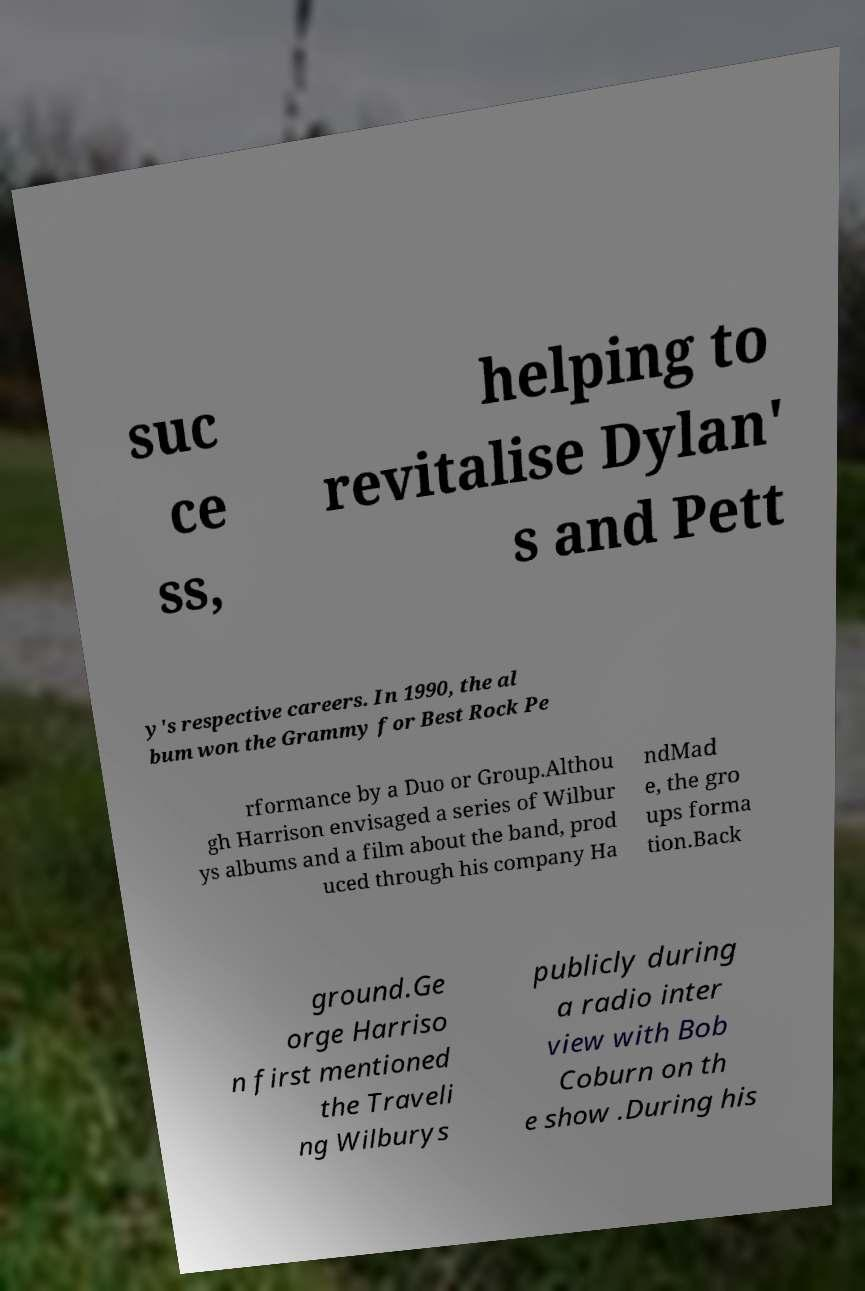I need the written content from this picture converted into text. Can you do that? suc ce ss, helping to revitalise Dylan' s and Pett y's respective careers. In 1990, the al bum won the Grammy for Best Rock Pe rformance by a Duo or Group.Althou gh Harrison envisaged a series of Wilbur ys albums and a film about the band, prod uced through his company Ha ndMad e, the gro ups forma tion.Back ground.Ge orge Harriso n first mentioned the Traveli ng Wilburys publicly during a radio inter view with Bob Coburn on th e show .During his 